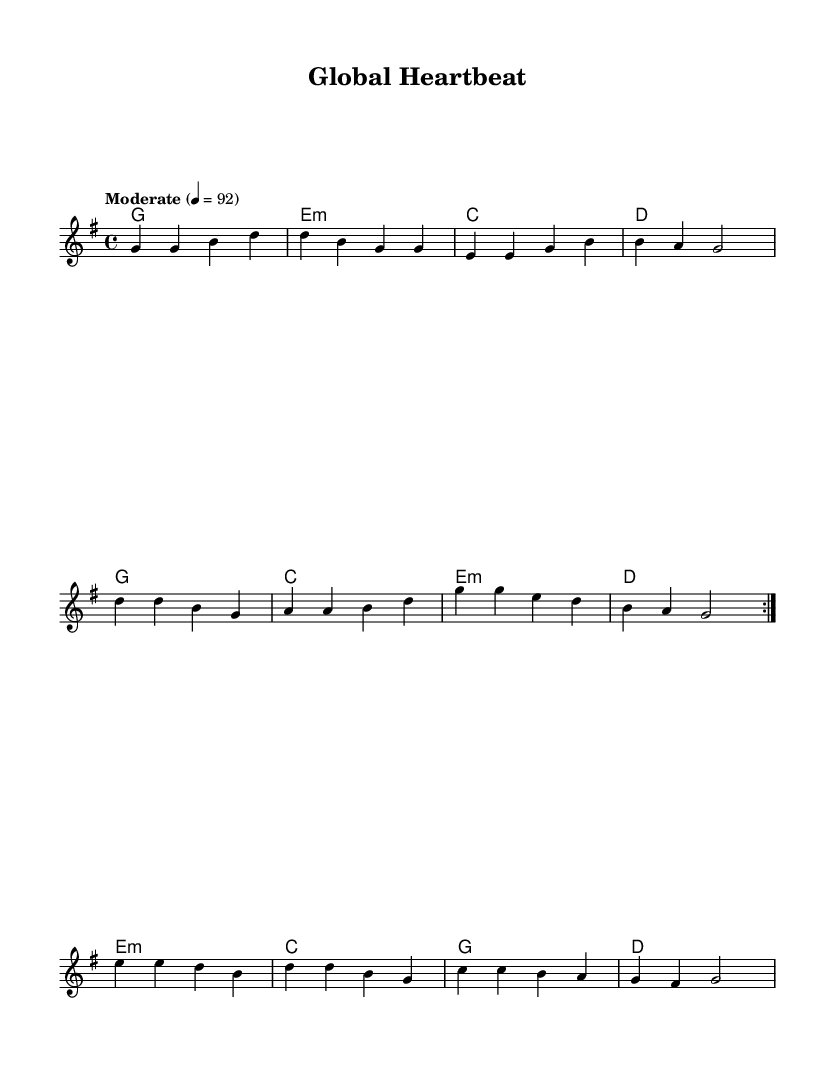What is the key signature of this music? The key signature is G major, which has one sharp (F#).
Answer: G major What is the time signature of this music? The time signature is 4/4, indicating four beats per measure.
Answer: 4/4 What is the tempo setting for this piece? The tempo marking is "Moderate" with a metronomic indication of quarter note equals 92 beats per minute.
Answer: Moderate, 92 How many measures are repeated in the melody section? The melody section has a repeat sign indicating that two measures are to be played twice.
Answer: 2 Which chord follows the G chord in the harmonies? In the sequence of chords, the G chord is followed by an E minor chord.
Answer: E minor How many different chords are used in the harmony section? There are a total of five distinct chords used in the harmony section: G, E minor, C, D, and E minor again.
Answer: 5 What is the starting note of the melody? The melody starts on the note G, which is the first note indicated in the melody.
Answer: G 